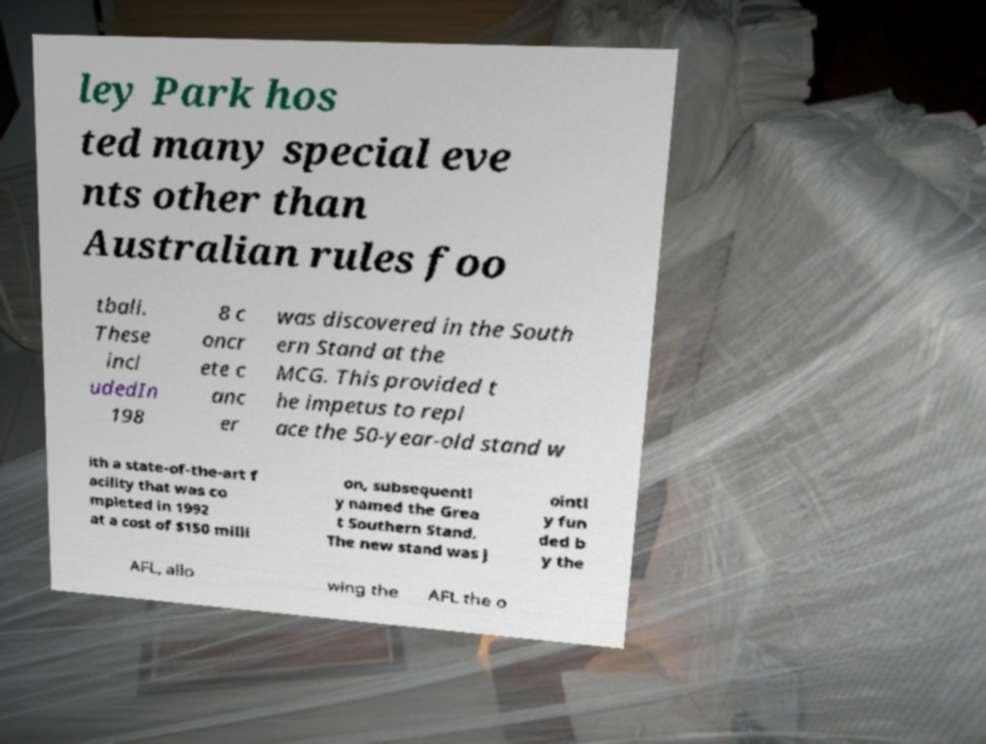For documentation purposes, I need the text within this image transcribed. Could you provide that? ley Park hos ted many special eve nts other than Australian rules foo tball. These incl udedIn 198 8 c oncr ete c anc er was discovered in the South ern Stand at the MCG. This provided t he impetus to repl ace the 50-year-old stand w ith a state-of-the-art f acility that was co mpleted in 1992 at a cost of $150 milli on, subsequentl y named the Grea t Southern Stand. The new stand was j ointl y fun ded b y the AFL, allo wing the AFL the o 